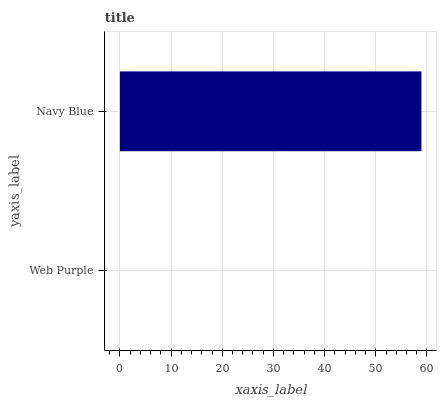Is Web Purple the minimum?
Answer yes or no. Yes. Is Navy Blue the maximum?
Answer yes or no. Yes. Is Navy Blue the minimum?
Answer yes or no. No. Is Navy Blue greater than Web Purple?
Answer yes or no. Yes. Is Web Purple less than Navy Blue?
Answer yes or no. Yes. Is Web Purple greater than Navy Blue?
Answer yes or no. No. Is Navy Blue less than Web Purple?
Answer yes or no. No. Is Navy Blue the high median?
Answer yes or no. Yes. Is Web Purple the low median?
Answer yes or no. Yes. Is Web Purple the high median?
Answer yes or no. No. Is Navy Blue the low median?
Answer yes or no. No. 